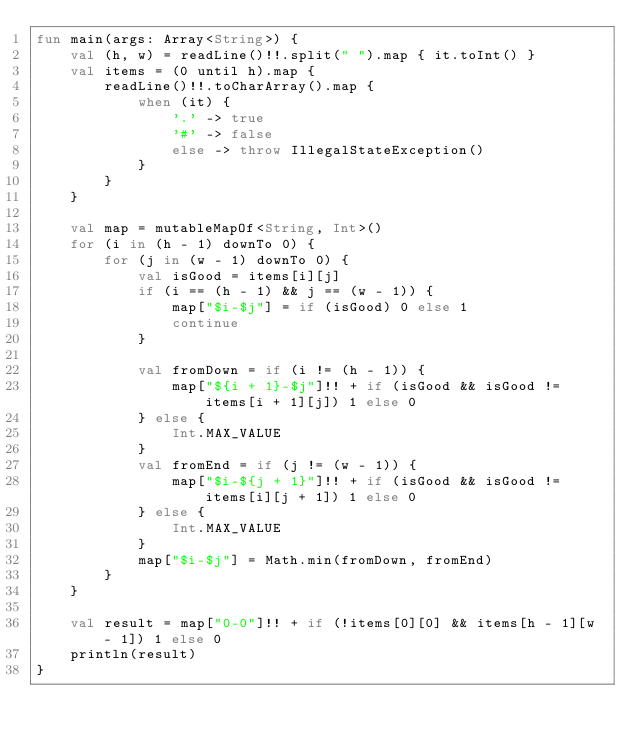Convert code to text. <code><loc_0><loc_0><loc_500><loc_500><_Kotlin_>fun main(args: Array<String>) {
    val (h, w) = readLine()!!.split(" ").map { it.toInt() }
    val items = (0 until h).map {
        readLine()!!.toCharArray().map {
            when (it) {
                '.' -> true
                '#' -> false
                else -> throw IllegalStateException()
            }
        }
    }

    val map = mutableMapOf<String, Int>()
    for (i in (h - 1) downTo 0) {
        for (j in (w - 1) downTo 0) {
            val isGood = items[i][j]
            if (i == (h - 1) && j == (w - 1)) {
                map["$i-$j"] = if (isGood) 0 else 1
                continue
            }

            val fromDown = if (i != (h - 1)) {
                map["${i + 1}-$j"]!! + if (isGood && isGood != items[i + 1][j]) 1 else 0
            } else {
                Int.MAX_VALUE
            }
            val fromEnd = if (j != (w - 1)) {
                map["$i-${j + 1}"]!! + if (isGood && isGood != items[i][j + 1]) 1 else 0
            } else {
                Int.MAX_VALUE
            }
            map["$i-$j"] = Math.min(fromDown, fromEnd)
        }
    }

    val result = map["0-0"]!! + if (!items[0][0] && items[h - 1][w - 1]) 1 else 0
    println(result)
}</code> 